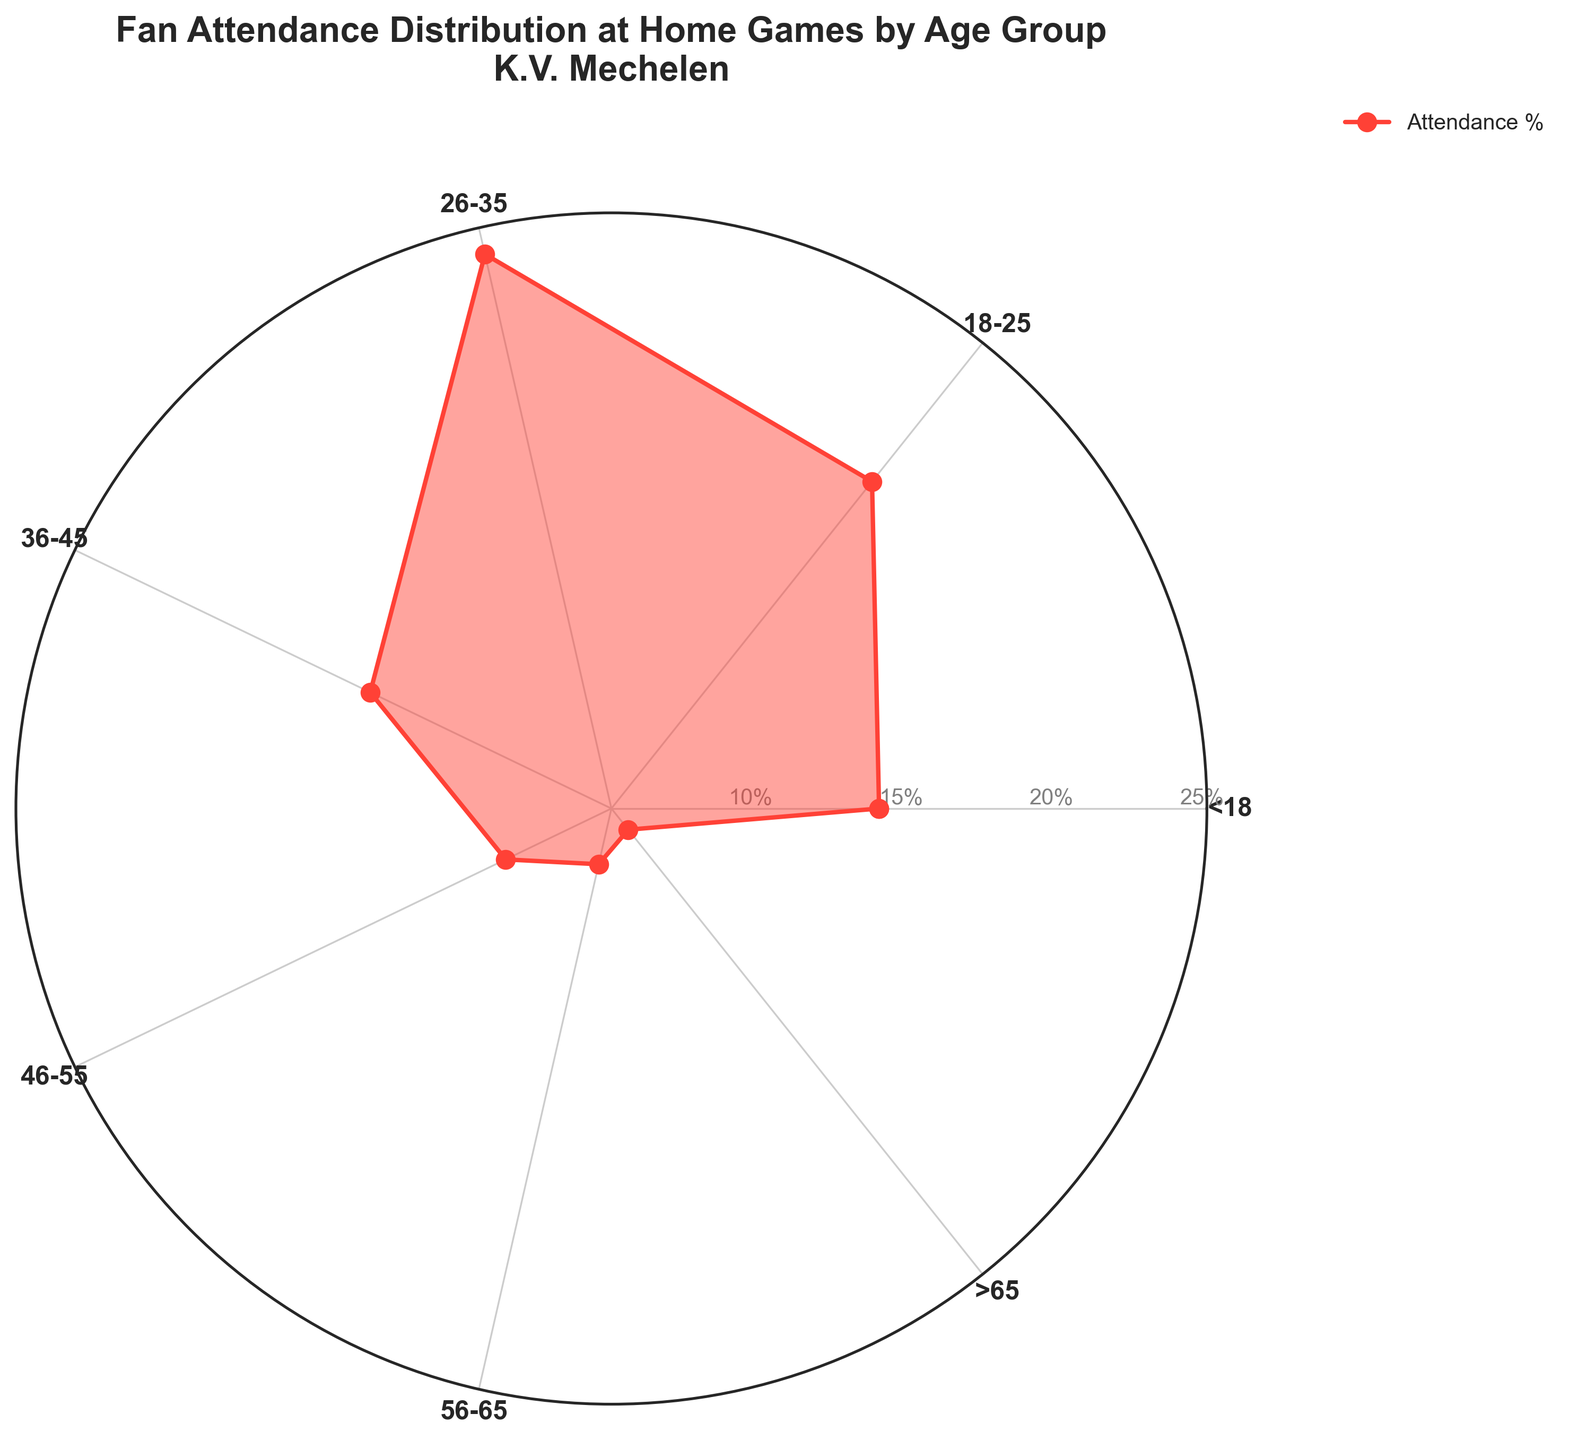Which age group has the highest fan attendance percentage? The fan attendance percentage for each age group is shown on the chart, and by comparing them, we can see that the 26-35 age group has the highest percentage at 25%.
Answer: 26-35 What's the combined fan attendance percentage for age groups under 18 and 18-25? To find the combined attendance, add the percentages for the <18 and 18-25 age groups. These are 15% and 20%, respectively. So, 15 + 20 = 35%.
Answer: 35% How does the percentage of fans aged 46-55 compare to those aged 36-45? Compare the percentage values for the 46-55 and 36-45 age groups. The 46-55 age group has a 10% attendance, whereas the 36-45 age group has 15%. Thus, 36-45 has a higher percentage.
Answer: 36-45 age group has a higher attendance What's the difference in fan attendance percentage between the youngest and oldest age groups? The youngest age group (<18) has an attendance of 15%, and the oldest age group (>65) has 7%. Subtract the latter from the former: 15 - 7 = 8%.
Answer: 8% Which is the least represented age group in the fan attendance? Identify the age group with the lowest percentage. The group >65 has the lowest at 7%.
Answer: >65 Is the percentage of fans aged 26-35 greater than the sum of those aged 56-65 and >65? Look at the percentages: 26-35 has 25%, 56-65 has 8%, and >65 has 7%. Sum the latter two: 8 + 7 = 15%, and compare: 25% > 15%.
Answer: Yes What is the percentage difference between the age groups 18-25 and 56-65? Subtract the percentage of the 56-65 age group (8%) from the 18-25 age group (20%): 20 - 8 = 12%.
Answer: 12% How do the categories' radial lines and filled areas indicate the data distribution? The radial lines start from the center and extend outwards. The filled areas indicate the magnitude, with larger areas representing higher percentages. For instance, the 26-35 group fills the most area, showing its highest percentage.
Answer: Larger filled area indicates higher attendance If you combine the attendance percentages of fans aged 18-25 and 26-35, how does that compare to the total attendance percentage of fans aged <18, 36-45, and >65? Sum the percentages of the 18-25 and 26-35 groups: 20 + 25 = 45%. Then sum the percentages of <18, 36-45, and >65: 15 + 15 + 7 = 37%. Compare the two sums: 45% > 37%.
Answer: Combined 18-25 and 26-35 is greater What's the average fan attendance percentage across all age groups? To find the average, sum all the percentages and divide by the number of age groups. Sum: 15 + 20 + 25 + 15 + 10 + 8 + 7 = 100, Number of groups: 7. Average = 100 / 7 ≈ 14.3%.
Answer: ≈ 14.3% 